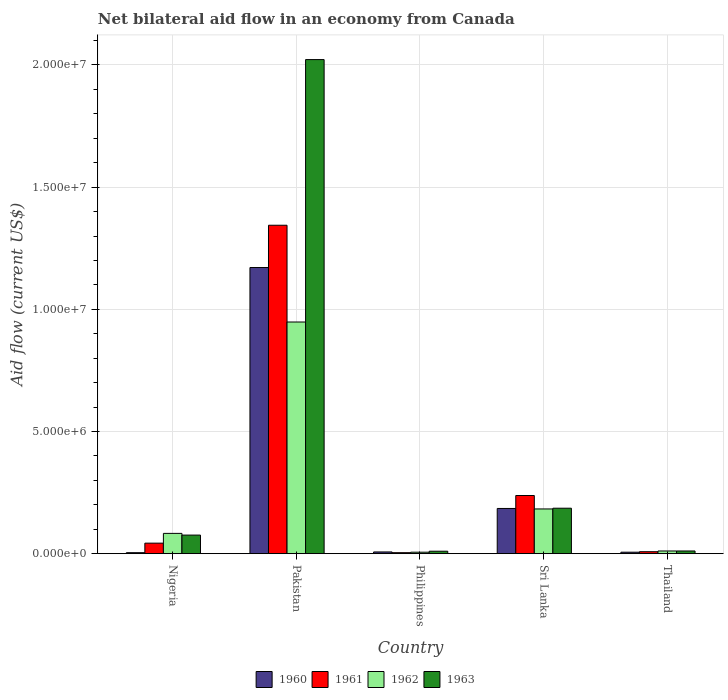How many groups of bars are there?
Ensure brevity in your answer.  5. Are the number of bars per tick equal to the number of legend labels?
Keep it short and to the point. Yes. How many bars are there on the 4th tick from the left?
Keep it short and to the point. 4. In how many cases, is the number of bars for a given country not equal to the number of legend labels?
Offer a very short reply. 0. Across all countries, what is the maximum net bilateral aid flow in 1962?
Your answer should be compact. 9.48e+06. In which country was the net bilateral aid flow in 1960 maximum?
Ensure brevity in your answer.  Pakistan. In which country was the net bilateral aid flow in 1960 minimum?
Ensure brevity in your answer.  Nigeria. What is the total net bilateral aid flow in 1962 in the graph?
Your answer should be compact. 1.23e+07. What is the difference between the net bilateral aid flow in 1962 in Pakistan and that in Sri Lanka?
Keep it short and to the point. 7.65e+06. What is the difference between the net bilateral aid flow in 1963 in Philippines and the net bilateral aid flow in 1962 in Nigeria?
Your answer should be very brief. -7.30e+05. What is the average net bilateral aid flow in 1960 per country?
Your answer should be compact. 2.75e+06. What is the difference between the net bilateral aid flow of/in 1961 and net bilateral aid flow of/in 1962 in Pakistan?
Provide a succinct answer. 3.96e+06. What is the ratio of the net bilateral aid flow in 1963 in Nigeria to that in Sri Lanka?
Keep it short and to the point. 0.41. Is the net bilateral aid flow in 1962 in Nigeria less than that in Pakistan?
Make the answer very short. Yes. Is the difference between the net bilateral aid flow in 1961 in Pakistan and Sri Lanka greater than the difference between the net bilateral aid flow in 1962 in Pakistan and Sri Lanka?
Offer a terse response. Yes. What is the difference between the highest and the second highest net bilateral aid flow in 1962?
Your response must be concise. 8.65e+06. What is the difference between the highest and the lowest net bilateral aid flow in 1960?
Offer a very short reply. 1.17e+07. In how many countries, is the net bilateral aid flow in 1963 greater than the average net bilateral aid flow in 1963 taken over all countries?
Provide a short and direct response. 1. Is it the case that in every country, the sum of the net bilateral aid flow in 1960 and net bilateral aid flow in 1963 is greater than the sum of net bilateral aid flow in 1962 and net bilateral aid flow in 1961?
Ensure brevity in your answer.  No. What does the 4th bar from the left in Thailand represents?
Make the answer very short. 1963. Are all the bars in the graph horizontal?
Your answer should be very brief. No. How many countries are there in the graph?
Provide a succinct answer. 5. What is the difference between two consecutive major ticks on the Y-axis?
Ensure brevity in your answer.  5.00e+06. Are the values on the major ticks of Y-axis written in scientific E-notation?
Provide a short and direct response. Yes. Does the graph contain any zero values?
Make the answer very short. No. What is the title of the graph?
Give a very brief answer. Net bilateral aid flow in an economy from Canada. What is the label or title of the X-axis?
Provide a succinct answer. Country. What is the label or title of the Y-axis?
Keep it short and to the point. Aid flow (current US$). What is the Aid flow (current US$) in 1962 in Nigeria?
Make the answer very short. 8.30e+05. What is the Aid flow (current US$) of 1963 in Nigeria?
Ensure brevity in your answer.  7.60e+05. What is the Aid flow (current US$) of 1960 in Pakistan?
Make the answer very short. 1.17e+07. What is the Aid flow (current US$) in 1961 in Pakistan?
Your answer should be compact. 1.34e+07. What is the Aid flow (current US$) of 1962 in Pakistan?
Offer a terse response. 9.48e+06. What is the Aid flow (current US$) in 1963 in Pakistan?
Your answer should be compact. 2.02e+07. What is the Aid flow (current US$) in 1962 in Philippines?
Offer a very short reply. 6.00e+04. What is the Aid flow (current US$) of 1963 in Philippines?
Provide a short and direct response. 1.00e+05. What is the Aid flow (current US$) of 1960 in Sri Lanka?
Your response must be concise. 1.85e+06. What is the Aid flow (current US$) of 1961 in Sri Lanka?
Provide a succinct answer. 2.38e+06. What is the Aid flow (current US$) in 1962 in Sri Lanka?
Keep it short and to the point. 1.83e+06. What is the Aid flow (current US$) in 1963 in Sri Lanka?
Ensure brevity in your answer.  1.86e+06. What is the Aid flow (current US$) in 1961 in Thailand?
Your answer should be very brief. 8.00e+04. What is the Aid flow (current US$) of 1963 in Thailand?
Your response must be concise. 1.10e+05. Across all countries, what is the maximum Aid flow (current US$) in 1960?
Your answer should be very brief. 1.17e+07. Across all countries, what is the maximum Aid flow (current US$) of 1961?
Offer a very short reply. 1.34e+07. Across all countries, what is the maximum Aid flow (current US$) of 1962?
Your response must be concise. 9.48e+06. Across all countries, what is the maximum Aid flow (current US$) in 1963?
Keep it short and to the point. 2.02e+07. Across all countries, what is the minimum Aid flow (current US$) in 1960?
Provide a short and direct response. 4.00e+04. Across all countries, what is the minimum Aid flow (current US$) in 1961?
Make the answer very short. 4.00e+04. What is the total Aid flow (current US$) in 1960 in the graph?
Keep it short and to the point. 1.37e+07. What is the total Aid flow (current US$) in 1961 in the graph?
Keep it short and to the point. 1.64e+07. What is the total Aid flow (current US$) of 1962 in the graph?
Keep it short and to the point. 1.23e+07. What is the total Aid flow (current US$) in 1963 in the graph?
Keep it short and to the point. 2.30e+07. What is the difference between the Aid flow (current US$) in 1960 in Nigeria and that in Pakistan?
Make the answer very short. -1.17e+07. What is the difference between the Aid flow (current US$) of 1961 in Nigeria and that in Pakistan?
Keep it short and to the point. -1.30e+07. What is the difference between the Aid flow (current US$) of 1962 in Nigeria and that in Pakistan?
Ensure brevity in your answer.  -8.65e+06. What is the difference between the Aid flow (current US$) in 1963 in Nigeria and that in Pakistan?
Give a very brief answer. -1.95e+07. What is the difference between the Aid flow (current US$) in 1960 in Nigeria and that in Philippines?
Your answer should be compact. -3.00e+04. What is the difference between the Aid flow (current US$) of 1961 in Nigeria and that in Philippines?
Provide a short and direct response. 3.90e+05. What is the difference between the Aid flow (current US$) in 1962 in Nigeria and that in Philippines?
Provide a short and direct response. 7.70e+05. What is the difference between the Aid flow (current US$) of 1963 in Nigeria and that in Philippines?
Offer a terse response. 6.60e+05. What is the difference between the Aid flow (current US$) of 1960 in Nigeria and that in Sri Lanka?
Ensure brevity in your answer.  -1.81e+06. What is the difference between the Aid flow (current US$) of 1961 in Nigeria and that in Sri Lanka?
Keep it short and to the point. -1.95e+06. What is the difference between the Aid flow (current US$) in 1962 in Nigeria and that in Sri Lanka?
Your response must be concise. -1.00e+06. What is the difference between the Aid flow (current US$) in 1963 in Nigeria and that in Sri Lanka?
Provide a short and direct response. -1.10e+06. What is the difference between the Aid flow (current US$) of 1960 in Nigeria and that in Thailand?
Your answer should be compact. -2.00e+04. What is the difference between the Aid flow (current US$) of 1962 in Nigeria and that in Thailand?
Keep it short and to the point. 7.20e+05. What is the difference between the Aid flow (current US$) of 1963 in Nigeria and that in Thailand?
Provide a succinct answer. 6.50e+05. What is the difference between the Aid flow (current US$) of 1960 in Pakistan and that in Philippines?
Your answer should be very brief. 1.16e+07. What is the difference between the Aid flow (current US$) of 1961 in Pakistan and that in Philippines?
Keep it short and to the point. 1.34e+07. What is the difference between the Aid flow (current US$) of 1962 in Pakistan and that in Philippines?
Your answer should be compact. 9.42e+06. What is the difference between the Aid flow (current US$) of 1963 in Pakistan and that in Philippines?
Your answer should be compact. 2.01e+07. What is the difference between the Aid flow (current US$) of 1960 in Pakistan and that in Sri Lanka?
Your answer should be compact. 9.86e+06. What is the difference between the Aid flow (current US$) of 1961 in Pakistan and that in Sri Lanka?
Ensure brevity in your answer.  1.11e+07. What is the difference between the Aid flow (current US$) in 1962 in Pakistan and that in Sri Lanka?
Give a very brief answer. 7.65e+06. What is the difference between the Aid flow (current US$) in 1963 in Pakistan and that in Sri Lanka?
Your answer should be compact. 1.84e+07. What is the difference between the Aid flow (current US$) of 1960 in Pakistan and that in Thailand?
Provide a short and direct response. 1.16e+07. What is the difference between the Aid flow (current US$) of 1961 in Pakistan and that in Thailand?
Offer a terse response. 1.34e+07. What is the difference between the Aid flow (current US$) in 1962 in Pakistan and that in Thailand?
Your response must be concise. 9.37e+06. What is the difference between the Aid flow (current US$) of 1963 in Pakistan and that in Thailand?
Your response must be concise. 2.01e+07. What is the difference between the Aid flow (current US$) of 1960 in Philippines and that in Sri Lanka?
Your answer should be compact. -1.78e+06. What is the difference between the Aid flow (current US$) in 1961 in Philippines and that in Sri Lanka?
Keep it short and to the point. -2.34e+06. What is the difference between the Aid flow (current US$) of 1962 in Philippines and that in Sri Lanka?
Offer a terse response. -1.77e+06. What is the difference between the Aid flow (current US$) of 1963 in Philippines and that in Sri Lanka?
Make the answer very short. -1.76e+06. What is the difference between the Aid flow (current US$) in 1962 in Philippines and that in Thailand?
Your answer should be very brief. -5.00e+04. What is the difference between the Aid flow (current US$) in 1960 in Sri Lanka and that in Thailand?
Make the answer very short. 1.79e+06. What is the difference between the Aid flow (current US$) in 1961 in Sri Lanka and that in Thailand?
Your answer should be very brief. 2.30e+06. What is the difference between the Aid flow (current US$) in 1962 in Sri Lanka and that in Thailand?
Ensure brevity in your answer.  1.72e+06. What is the difference between the Aid flow (current US$) of 1963 in Sri Lanka and that in Thailand?
Give a very brief answer. 1.75e+06. What is the difference between the Aid flow (current US$) in 1960 in Nigeria and the Aid flow (current US$) in 1961 in Pakistan?
Provide a succinct answer. -1.34e+07. What is the difference between the Aid flow (current US$) of 1960 in Nigeria and the Aid flow (current US$) of 1962 in Pakistan?
Offer a terse response. -9.44e+06. What is the difference between the Aid flow (current US$) in 1960 in Nigeria and the Aid flow (current US$) in 1963 in Pakistan?
Keep it short and to the point. -2.02e+07. What is the difference between the Aid flow (current US$) in 1961 in Nigeria and the Aid flow (current US$) in 1962 in Pakistan?
Provide a succinct answer. -9.05e+06. What is the difference between the Aid flow (current US$) in 1961 in Nigeria and the Aid flow (current US$) in 1963 in Pakistan?
Your answer should be very brief. -1.98e+07. What is the difference between the Aid flow (current US$) of 1962 in Nigeria and the Aid flow (current US$) of 1963 in Pakistan?
Make the answer very short. -1.94e+07. What is the difference between the Aid flow (current US$) in 1960 in Nigeria and the Aid flow (current US$) in 1961 in Philippines?
Your response must be concise. 0. What is the difference between the Aid flow (current US$) in 1960 in Nigeria and the Aid flow (current US$) in 1962 in Philippines?
Give a very brief answer. -2.00e+04. What is the difference between the Aid flow (current US$) in 1960 in Nigeria and the Aid flow (current US$) in 1963 in Philippines?
Your answer should be very brief. -6.00e+04. What is the difference between the Aid flow (current US$) in 1961 in Nigeria and the Aid flow (current US$) in 1962 in Philippines?
Your response must be concise. 3.70e+05. What is the difference between the Aid flow (current US$) in 1962 in Nigeria and the Aid flow (current US$) in 1963 in Philippines?
Give a very brief answer. 7.30e+05. What is the difference between the Aid flow (current US$) of 1960 in Nigeria and the Aid flow (current US$) of 1961 in Sri Lanka?
Provide a short and direct response. -2.34e+06. What is the difference between the Aid flow (current US$) in 1960 in Nigeria and the Aid flow (current US$) in 1962 in Sri Lanka?
Offer a terse response. -1.79e+06. What is the difference between the Aid flow (current US$) in 1960 in Nigeria and the Aid flow (current US$) in 1963 in Sri Lanka?
Offer a terse response. -1.82e+06. What is the difference between the Aid flow (current US$) in 1961 in Nigeria and the Aid flow (current US$) in 1962 in Sri Lanka?
Provide a succinct answer. -1.40e+06. What is the difference between the Aid flow (current US$) of 1961 in Nigeria and the Aid flow (current US$) of 1963 in Sri Lanka?
Your answer should be very brief. -1.43e+06. What is the difference between the Aid flow (current US$) of 1962 in Nigeria and the Aid flow (current US$) of 1963 in Sri Lanka?
Make the answer very short. -1.03e+06. What is the difference between the Aid flow (current US$) in 1960 in Nigeria and the Aid flow (current US$) in 1961 in Thailand?
Offer a terse response. -4.00e+04. What is the difference between the Aid flow (current US$) of 1960 in Nigeria and the Aid flow (current US$) of 1962 in Thailand?
Your answer should be very brief. -7.00e+04. What is the difference between the Aid flow (current US$) of 1960 in Nigeria and the Aid flow (current US$) of 1963 in Thailand?
Your response must be concise. -7.00e+04. What is the difference between the Aid flow (current US$) of 1961 in Nigeria and the Aid flow (current US$) of 1962 in Thailand?
Keep it short and to the point. 3.20e+05. What is the difference between the Aid flow (current US$) in 1961 in Nigeria and the Aid flow (current US$) in 1963 in Thailand?
Offer a terse response. 3.20e+05. What is the difference between the Aid flow (current US$) in 1962 in Nigeria and the Aid flow (current US$) in 1963 in Thailand?
Provide a succinct answer. 7.20e+05. What is the difference between the Aid flow (current US$) in 1960 in Pakistan and the Aid flow (current US$) in 1961 in Philippines?
Your response must be concise. 1.17e+07. What is the difference between the Aid flow (current US$) in 1960 in Pakistan and the Aid flow (current US$) in 1962 in Philippines?
Offer a very short reply. 1.16e+07. What is the difference between the Aid flow (current US$) of 1960 in Pakistan and the Aid flow (current US$) of 1963 in Philippines?
Make the answer very short. 1.16e+07. What is the difference between the Aid flow (current US$) of 1961 in Pakistan and the Aid flow (current US$) of 1962 in Philippines?
Make the answer very short. 1.34e+07. What is the difference between the Aid flow (current US$) of 1961 in Pakistan and the Aid flow (current US$) of 1963 in Philippines?
Your answer should be very brief. 1.33e+07. What is the difference between the Aid flow (current US$) in 1962 in Pakistan and the Aid flow (current US$) in 1963 in Philippines?
Offer a terse response. 9.38e+06. What is the difference between the Aid flow (current US$) of 1960 in Pakistan and the Aid flow (current US$) of 1961 in Sri Lanka?
Give a very brief answer. 9.33e+06. What is the difference between the Aid flow (current US$) in 1960 in Pakistan and the Aid flow (current US$) in 1962 in Sri Lanka?
Keep it short and to the point. 9.88e+06. What is the difference between the Aid flow (current US$) of 1960 in Pakistan and the Aid flow (current US$) of 1963 in Sri Lanka?
Give a very brief answer. 9.85e+06. What is the difference between the Aid flow (current US$) in 1961 in Pakistan and the Aid flow (current US$) in 1962 in Sri Lanka?
Keep it short and to the point. 1.16e+07. What is the difference between the Aid flow (current US$) in 1961 in Pakistan and the Aid flow (current US$) in 1963 in Sri Lanka?
Your answer should be very brief. 1.16e+07. What is the difference between the Aid flow (current US$) of 1962 in Pakistan and the Aid flow (current US$) of 1963 in Sri Lanka?
Offer a very short reply. 7.62e+06. What is the difference between the Aid flow (current US$) in 1960 in Pakistan and the Aid flow (current US$) in 1961 in Thailand?
Your answer should be very brief. 1.16e+07. What is the difference between the Aid flow (current US$) in 1960 in Pakistan and the Aid flow (current US$) in 1962 in Thailand?
Offer a very short reply. 1.16e+07. What is the difference between the Aid flow (current US$) in 1960 in Pakistan and the Aid flow (current US$) in 1963 in Thailand?
Provide a short and direct response. 1.16e+07. What is the difference between the Aid flow (current US$) in 1961 in Pakistan and the Aid flow (current US$) in 1962 in Thailand?
Your response must be concise. 1.33e+07. What is the difference between the Aid flow (current US$) in 1961 in Pakistan and the Aid flow (current US$) in 1963 in Thailand?
Offer a terse response. 1.33e+07. What is the difference between the Aid flow (current US$) of 1962 in Pakistan and the Aid flow (current US$) of 1963 in Thailand?
Ensure brevity in your answer.  9.37e+06. What is the difference between the Aid flow (current US$) in 1960 in Philippines and the Aid flow (current US$) in 1961 in Sri Lanka?
Make the answer very short. -2.31e+06. What is the difference between the Aid flow (current US$) in 1960 in Philippines and the Aid flow (current US$) in 1962 in Sri Lanka?
Provide a succinct answer. -1.76e+06. What is the difference between the Aid flow (current US$) of 1960 in Philippines and the Aid flow (current US$) of 1963 in Sri Lanka?
Provide a short and direct response. -1.79e+06. What is the difference between the Aid flow (current US$) in 1961 in Philippines and the Aid flow (current US$) in 1962 in Sri Lanka?
Your response must be concise. -1.79e+06. What is the difference between the Aid flow (current US$) in 1961 in Philippines and the Aid flow (current US$) in 1963 in Sri Lanka?
Your answer should be very brief. -1.82e+06. What is the difference between the Aid flow (current US$) of 1962 in Philippines and the Aid flow (current US$) of 1963 in Sri Lanka?
Give a very brief answer. -1.80e+06. What is the difference between the Aid flow (current US$) of 1960 in Philippines and the Aid flow (current US$) of 1963 in Thailand?
Keep it short and to the point. -4.00e+04. What is the difference between the Aid flow (current US$) of 1961 in Philippines and the Aid flow (current US$) of 1963 in Thailand?
Offer a very short reply. -7.00e+04. What is the difference between the Aid flow (current US$) in 1960 in Sri Lanka and the Aid flow (current US$) in 1961 in Thailand?
Offer a terse response. 1.77e+06. What is the difference between the Aid flow (current US$) of 1960 in Sri Lanka and the Aid flow (current US$) of 1962 in Thailand?
Offer a terse response. 1.74e+06. What is the difference between the Aid flow (current US$) of 1960 in Sri Lanka and the Aid flow (current US$) of 1963 in Thailand?
Provide a short and direct response. 1.74e+06. What is the difference between the Aid flow (current US$) in 1961 in Sri Lanka and the Aid flow (current US$) in 1962 in Thailand?
Provide a succinct answer. 2.27e+06. What is the difference between the Aid flow (current US$) in 1961 in Sri Lanka and the Aid flow (current US$) in 1963 in Thailand?
Your answer should be very brief. 2.27e+06. What is the difference between the Aid flow (current US$) in 1962 in Sri Lanka and the Aid flow (current US$) in 1963 in Thailand?
Your answer should be very brief. 1.72e+06. What is the average Aid flow (current US$) in 1960 per country?
Provide a short and direct response. 2.75e+06. What is the average Aid flow (current US$) of 1961 per country?
Offer a terse response. 3.27e+06. What is the average Aid flow (current US$) of 1962 per country?
Ensure brevity in your answer.  2.46e+06. What is the average Aid flow (current US$) in 1963 per country?
Make the answer very short. 4.61e+06. What is the difference between the Aid flow (current US$) in 1960 and Aid flow (current US$) in 1961 in Nigeria?
Your response must be concise. -3.90e+05. What is the difference between the Aid flow (current US$) of 1960 and Aid flow (current US$) of 1962 in Nigeria?
Your response must be concise. -7.90e+05. What is the difference between the Aid flow (current US$) of 1960 and Aid flow (current US$) of 1963 in Nigeria?
Keep it short and to the point. -7.20e+05. What is the difference between the Aid flow (current US$) in 1961 and Aid flow (current US$) in 1962 in Nigeria?
Your answer should be compact. -4.00e+05. What is the difference between the Aid flow (current US$) of 1961 and Aid flow (current US$) of 1963 in Nigeria?
Offer a terse response. -3.30e+05. What is the difference between the Aid flow (current US$) in 1962 and Aid flow (current US$) in 1963 in Nigeria?
Keep it short and to the point. 7.00e+04. What is the difference between the Aid flow (current US$) in 1960 and Aid flow (current US$) in 1961 in Pakistan?
Make the answer very short. -1.73e+06. What is the difference between the Aid flow (current US$) of 1960 and Aid flow (current US$) of 1962 in Pakistan?
Your response must be concise. 2.23e+06. What is the difference between the Aid flow (current US$) in 1960 and Aid flow (current US$) in 1963 in Pakistan?
Provide a succinct answer. -8.51e+06. What is the difference between the Aid flow (current US$) of 1961 and Aid flow (current US$) of 1962 in Pakistan?
Offer a terse response. 3.96e+06. What is the difference between the Aid flow (current US$) of 1961 and Aid flow (current US$) of 1963 in Pakistan?
Your answer should be very brief. -6.78e+06. What is the difference between the Aid flow (current US$) of 1962 and Aid flow (current US$) of 1963 in Pakistan?
Your answer should be compact. -1.07e+07. What is the difference between the Aid flow (current US$) in 1960 and Aid flow (current US$) in 1961 in Philippines?
Provide a short and direct response. 3.00e+04. What is the difference between the Aid flow (current US$) in 1960 and Aid flow (current US$) in 1963 in Philippines?
Offer a terse response. -3.00e+04. What is the difference between the Aid flow (current US$) in 1960 and Aid flow (current US$) in 1961 in Sri Lanka?
Make the answer very short. -5.30e+05. What is the difference between the Aid flow (current US$) in 1961 and Aid flow (current US$) in 1963 in Sri Lanka?
Offer a terse response. 5.20e+05. What is the difference between the Aid flow (current US$) of 1960 and Aid flow (current US$) of 1962 in Thailand?
Give a very brief answer. -5.00e+04. What is the difference between the Aid flow (current US$) of 1961 and Aid flow (current US$) of 1963 in Thailand?
Provide a short and direct response. -3.00e+04. What is the ratio of the Aid flow (current US$) of 1960 in Nigeria to that in Pakistan?
Your response must be concise. 0. What is the ratio of the Aid flow (current US$) of 1961 in Nigeria to that in Pakistan?
Ensure brevity in your answer.  0.03. What is the ratio of the Aid flow (current US$) of 1962 in Nigeria to that in Pakistan?
Offer a terse response. 0.09. What is the ratio of the Aid flow (current US$) in 1963 in Nigeria to that in Pakistan?
Give a very brief answer. 0.04. What is the ratio of the Aid flow (current US$) in 1961 in Nigeria to that in Philippines?
Make the answer very short. 10.75. What is the ratio of the Aid flow (current US$) of 1962 in Nigeria to that in Philippines?
Your response must be concise. 13.83. What is the ratio of the Aid flow (current US$) in 1960 in Nigeria to that in Sri Lanka?
Your response must be concise. 0.02. What is the ratio of the Aid flow (current US$) in 1961 in Nigeria to that in Sri Lanka?
Provide a short and direct response. 0.18. What is the ratio of the Aid flow (current US$) in 1962 in Nigeria to that in Sri Lanka?
Ensure brevity in your answer.  0.45. What is the ratio of the Aid flow (current US$) of 1963 in Nigeria to that in Sri Lanka?
Ensure brevity in your answer.  0.41. What is the ratio of the Aid flow (current US$) of 1960 in Nigeria to that in Thailand?
Offer a very short reply. 0.67. What is the ratio of the Aid flow (current US$) in 1961 in Nigeria to that in Thailand?
Offer a terse response. 5.38. What is the ratio of the Aid flow (current US$) of 1962 in Nigeria to that in Thailand?
Your response must be concise. 7.55. What is the ratio of the Aid flow (current US$) of 1963 in Nigeria to that in Thailand?
Offer a terse response. 6.91. What is the ratio of the Aid flow (current US$) in 1960 in Pakistan to that in Philippines?
Your answer should be very brief. 167.29. What is the ratio of the Aid flow (current US$) of 1961 in Pakistan to that in Philippines?
Provide a succinct answer. 336. What is the ratio of the Aid flow (current US$) in 1962 in Pakistan to that in Philippines?
Offer a terse response. 158. What is the ratio of the Aid flow (current US$) in 1963 in Pakistan to that in Philippines?
Ensure brevity in your answer.  202.2. What is the ratio of the Aid flow (current US$) in 1960 in Pakistan to that in Sri Lanka?
Offer a very short reply. 6.33. What is the ratio of the Aid flow (current US$) in 1961 in Pakistan to that in Sri Lanka?
Ensure brevity in your answer.  5.65. What is the ratio of the Aid flow (current US$) of 1962 in Pakistan to that in Sri Lanka?
Provide a short and direct response. 5.18. What is the ratio of the Aid flow (current US$) of 1963 in Pakistan to that in Sri Lanka?
Ensure brevity in your answer.  10.87. What is the ratio of the Aid flow (current US$) in 1960 in Pakistan to that in Thailand?
Your answer should be compact. 195.17. What is the ratio of the Aid flow (current US$) of 1961 in Pakistan to that in Thailand?
Your answer should be compact. 168. What is the ratio of the Aid flow (current US$) in 1962 in Pakistan to that in Thailand?
Offer a terse response. 86.18. What is the ratio of the Aid flow (current US$) of 1963 in Pakistan to that in Thailand?
Your response must be concise. 183.82. What is the ratio of the Aid flow (current US$) in 1960 in Philippines to that in Sri Lanka?
Provide a succinct answer. 0.04. What is the ratio of the Aid flow (current US$) in 1961 in Philippines to that in Sri Lanka?
Offer a terse response. 0.02. What is the ratio of the Aid flow (current US$) in 1962 in Philippines to that in Sri Lanka?
Your answer should be compact. 0.03. What is the ratio of the Aid flow (current US$) in 1963 in Philippines to that in Sri Lanka?
Your response must be concise. 0.05. What is the ratio of the Aid flow (current US$) of 1960 in Philippines to that in Thailand?
Give a very brief answer. 1.17. What is the ratio of the Aid flow (current US$) in 1961 in Philippines to that in Thailand?
Make the answer very short. 0.5. What is the ratio of the Aid flow (current US$) of 1962 in Philippines to that in Thailand?
Offer a terse response. 0.55. What is the ratio of the Aid flow (current US$) in 1963 in Philippines to that in Thailand?
Keep it short and to the point. 0.91. What is the ratio of the Aid flow (current US$) of 1960 in Sri Lanka to that in Thailand?
Your response must be concise. 30.83. What is the ratio of the Aid flow (current US$) of 1961 in Sri Lanka to that in Thailand?
Provide a succinct answer. 29.75. What is the ratio of the Aid flow (current US$) in 1962 in Sri Lanka to that in Thailand?
Keep it short and to the point. 16.64. What is the ratio of the Aid flow (current US$) in 1963 in Sri Lanka to that in Thailand?
Provide a succinct answer. 16.91. What is the difference between the highest and the second highest Aid flow (current US$) in 1960?
Your answer should be very brief. 9.86e+06. What is the difference between the highest and the second highest Aid flow (current US$) of 1961?
Ensure brevity in your answer.  1.11e+07. What is the difference between the highest and the second highest Aid flow (current US$) of 1962?
Keep it short and to the point. 7.65e+06. What is the difference between the highest and the second highest Aid flow (current US$) of 1963?
Provide a succinct answer. 1.84e+07. What is the difference between the highest and the lowest Aid flow (current US$) in 1960?
Your response must be concise. 1.17e+07. What is the difference between the highest and the lowest Aid flow (current US$) of 1961?
Keep it short and to the point. 1.34e+07. What is the difference between the highest and the lowest Aid flow (current US$) in 1962?
Give a very brief answer. 9.42e+06. What is the difference between the highest and the lowest Aid flow (current US$) of 1963?
Offer a terse response. 2.01e+07. 